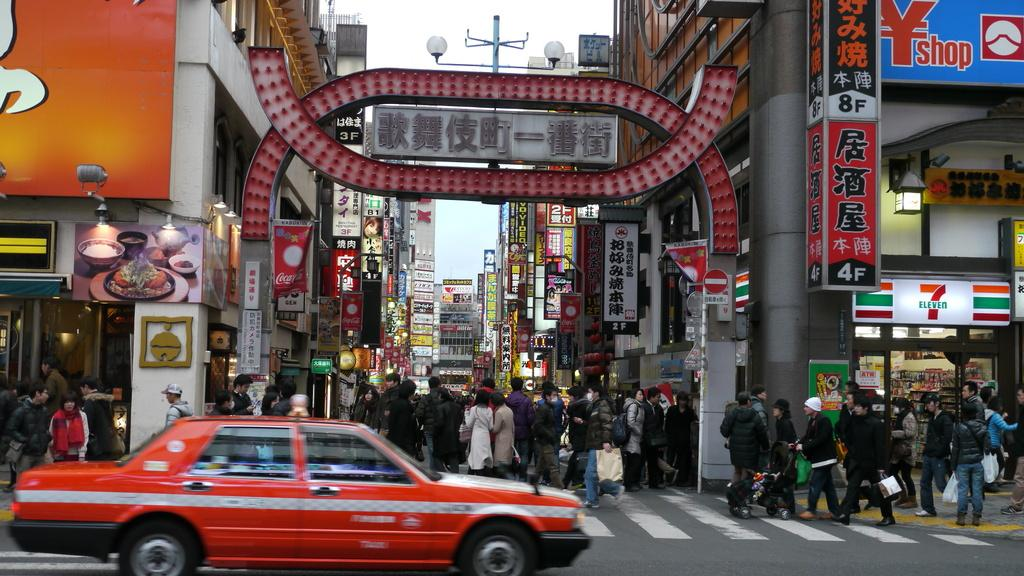<image>
Share a concise interpretation of the image provided. The shop on the right hand side is a 7 eleven shop. 